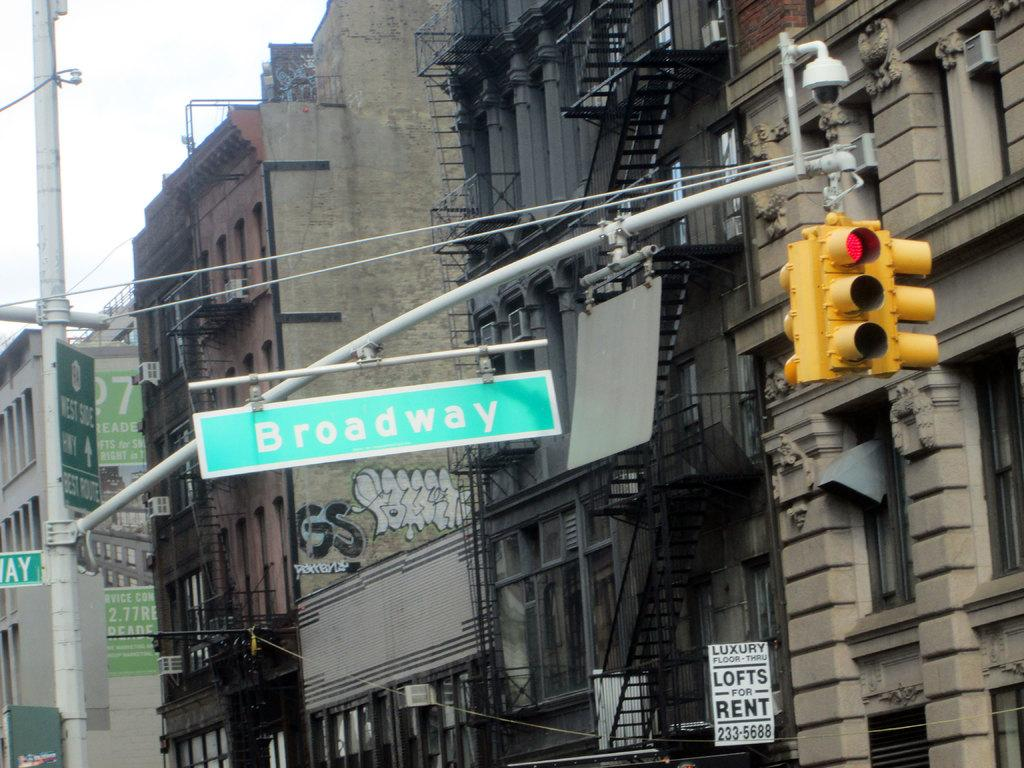<image>
Offer a succinct explanation of the picture presented. Lofts are for rent in the building near Broadway. 